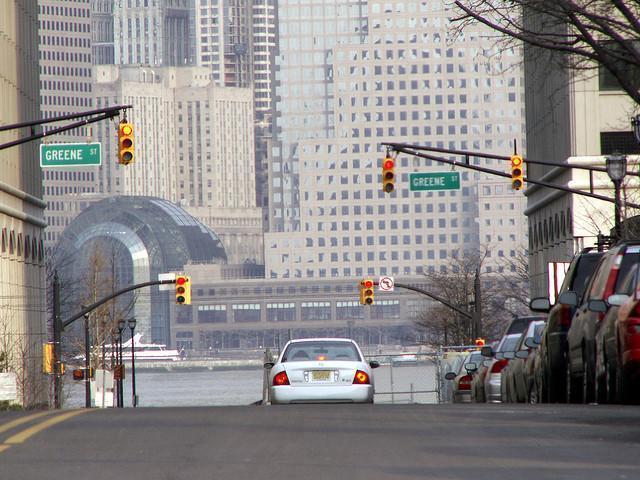How many white cars are in operation?
Give a very brief answer. 1. How many cars are in the picture?
Give a very brief answer. 4. How many chairs are there?
Give a very brief answer. 0. 